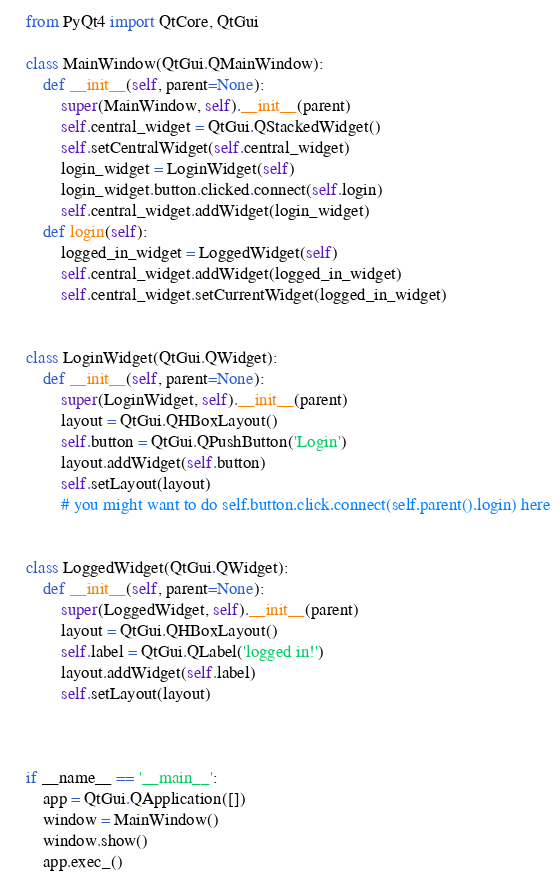<code> <loc_0><loc_0><loc_500><loc_500><_Python_>    from PyQt4 import QtCore, QtGui

    class MainWindow(QtGui.QMainWindow):
        def __init__(self, parent=None):
            super(MainWindow, self).__init__(parent)
            self.central_widget = QtGui.QStackedWidget()
            self.setCentralWidget(self.central_widget)
            login_widget = LoginWidget(self)
            login_widget.button.clicked.connect(self.login)
            self.central_widget.addWidget(login_widget)
        def login(self):
            logged_in_widget = LoggedWidget(self)
            self.central_widget.addWidget(logged_in_widget)
            self.central_widget.setCurrentWidget(logged_in_widget)


    class LoginWidget(QtGui.QWidget):
        def __init__(self, parent=None):
            super(LoginWidget, self).__init__(parent)
            layout = QtGui.QHBoxLayout()
            self.button = QtGui.QPushButton('Login')
            layout.addWidget(self.button)
            self.setLayout(layout)
            # you might want to do self.button.click.connect(self.parent().login) here


    class LoggedWidget(QtGui.QWidget):
        def __init__(self, parent=None):
            super(LoggedWidget, self).__init__(parent)
            layout = QtGui.QHBoxLayout()
            self.label = QtGui.QLabel('logged in!')
            layout.addWidget(self.label)
            self.setLayout(layout)



    if __name__ == '__main__':
        app = QtGui.QApplication([])
        window = MainWindow()
        window.show()
        app.exec_()</code> 